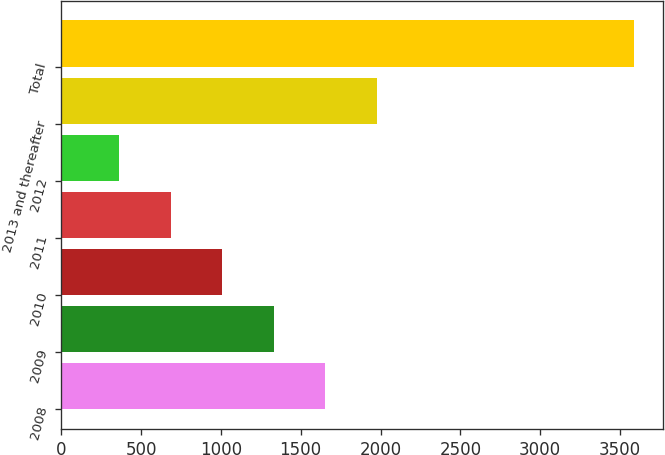Convert chart to OTSL. <chart><loc_0><loc_0><loc_500><loc_500><bar_chart><fcel>2008<fcel>2009<fcel>2010<fcel>2011<fcel>2012<fcel>2013 and thereafter<fcel>Total<nl><fcel>1653.82<fcel>1331.64<fcel>1009.46<fcel>687.28<fcel>365.1<fcel>1976<fcel>3586.9<nl></chart> 